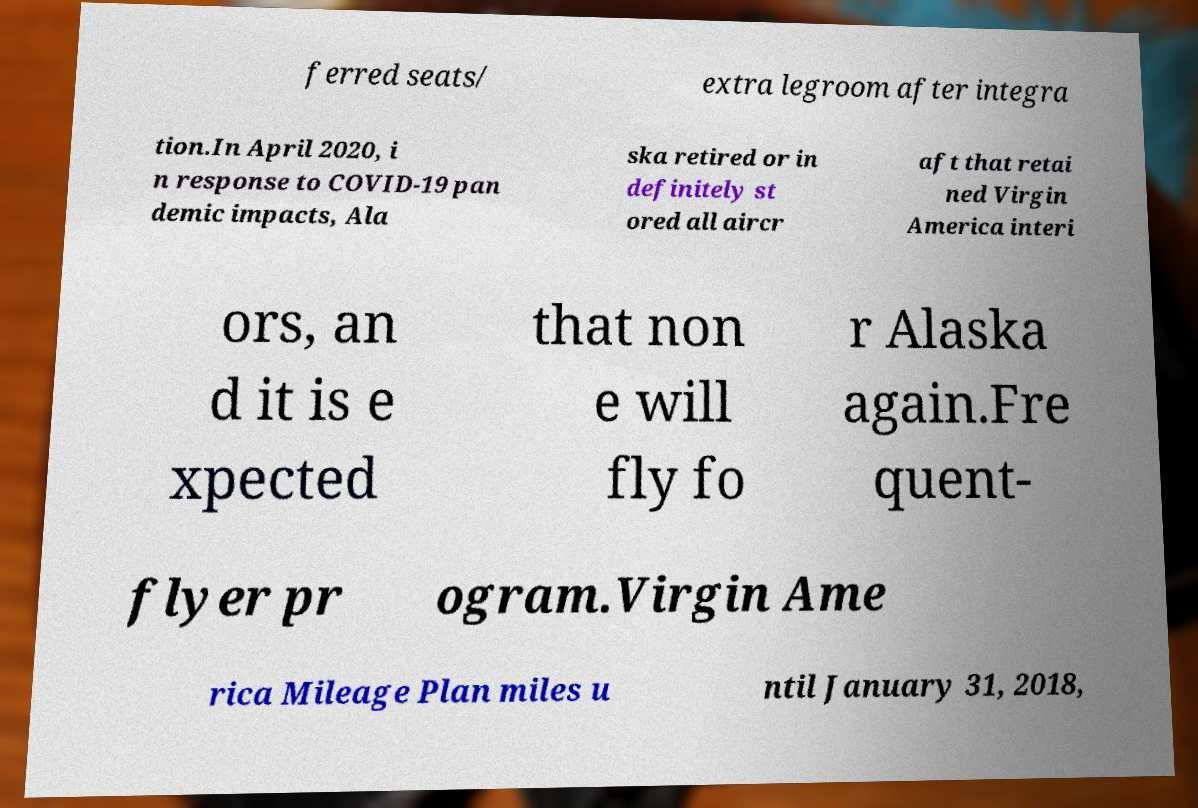Could you extract and type out the text from this image? ferred seats/ extra legroom after integra tion.In April 2020, i n response to COVID-19 pan demic impacts, Ala ska retired or in definitely st ored all aircr aft that retai ned Virgin America interi ors, an d it is e xpected that non e will fly fo r Alaska again.Fre quent- flyer pr ogram.Virgin Ame rica Mileage Plan miles u ntil January 31, 2018, 